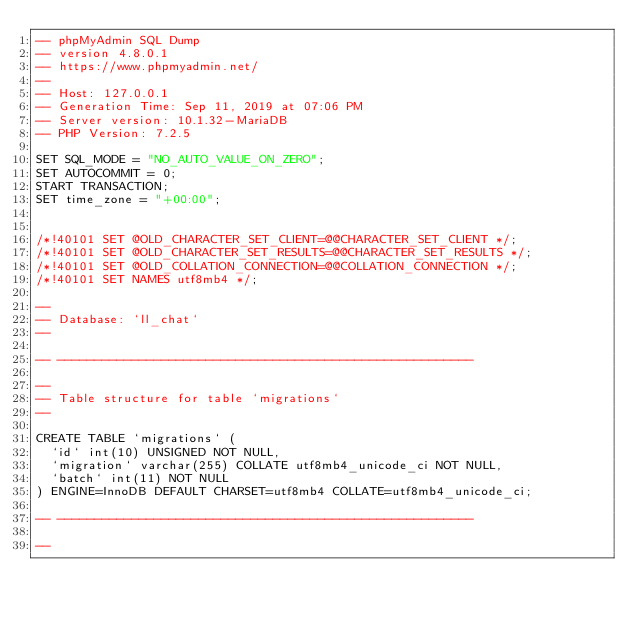<code> <loc_0><loc_0><loc_500><loc_500><_SQL_>-- phpMyAdmin SQL Dump
-- version 4.8.0.1
-- https://www.phpmyadmin.net/
--
-- Host: 127.0.0.1
-- Generation Time: Sep 11, 2019 at 07:06 PM
-- Server version: 10.1.32-MariaDB
-- PHP Version: 7.2.5

SET SQL_MODE = "NO_AUTO_VALUE_ON_ZERO";
SET AUTOCOMMIT = 0;
START TRANSACTION;
SET time_zone = "+00:00";


/*!40101 SET @OLD_CHARACTER_SET_CLIENT=@@CHARACTER_SET_CLIENT */;
/*!40101 SET @OLD_CHARACTER_SET_RESULTS=@@CHARACTER_SET_RESULTS */;
/*!40101 SET @OLD_COLLATION_CONNECTION=@@COLLATION_CONNECTION */;
/*!40101 SET NAMES utf8mb4 */;

--
-- Database: `ll_chat`
--

-- --------------------------------------------------------

--
-- Table structure for table `migrations`
--

CREATE TABLE `migrations` (
  `id` int(10) UNSIGNED NOT NULL,
  `migration` varchar(255) COLLATE utf8mb4_unicode_ci NOT NULL,
  `batch` int(11) NOT NULL
) ENGINE=InnoDB DEFAULT CHARSET=utf8mb4 COLLATE=utf8mb4_unicode_ci;

-- --------------------------------------------------------

--</code> 